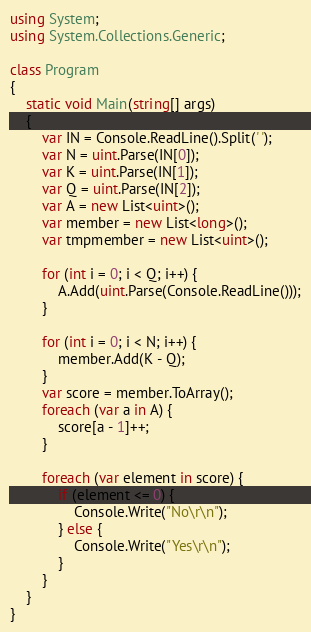Convert code to text. <code><loc_0><loc_0><loc_500><loc_500><_C#_>using System;
using System.Collections.Generic;

class Program
{
	static void Main(string[] args)
	{
		var IN = Console.ReadLine().Split(' ');
		var N = uint.Parse(IN[0]);
		var K = uint.Parse(IN[1]);
		var Q = uint.Parse(IN[2]);
		var A = new List<uint>();
		var member = new List<long>();
		var tmpmember = new List<uint>();
		
		for (int i = 0; i < Q; i++) {
			A.Add(uint.Parse(Console.ReadLine()));
		}
		
		for (int i = 0; i < N; i++) {
			member.Add(K - Q);
		}
		var score = member.ToArray();
		foreach (var a in A) {
			score[a - 1]++;
		}
		
		foreach (var element in score) {
			if (element <= 0) {
				Console.Write("No\r\n");
			} else {
				Console.Write("Yes\r\n");
			}
		}
	}
}</code> 